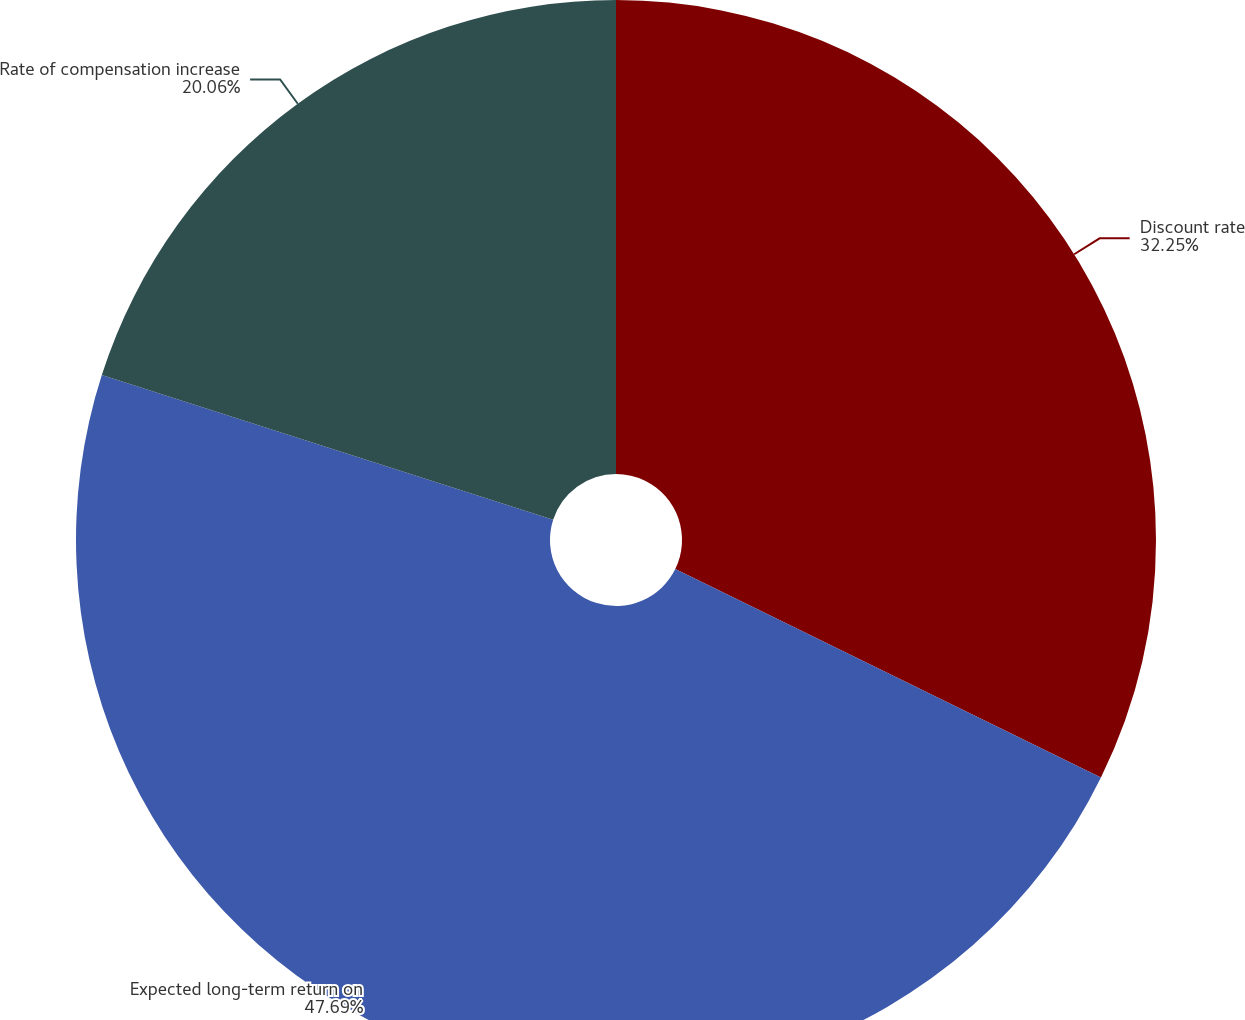Convert chart. <chart><loc_0><loc_0><loc_500><loc_500><pie_chart><fcel>Discount rate<fcel>Expected long-term return on<fcel>Rate of compensation increase<nl><fcel>32.25%<fcel>47.69%<fcel>20.06%<nl></chart> 